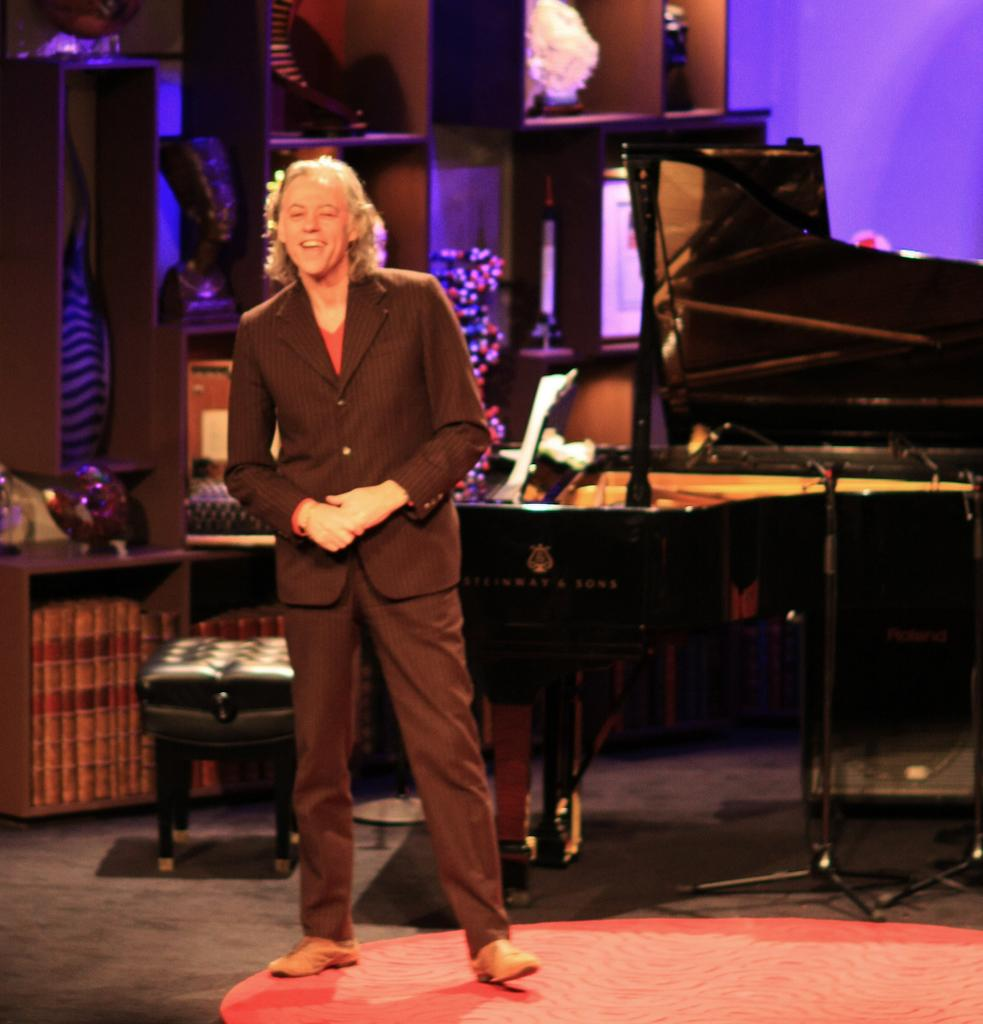What is at the bottom of the image? There is a floor at the bottom of the image. Who or what is in the foreground of the image? There is a person and a chair in the foreground of the image. What is the person doing in the image? The person is likely playing musical instruments, as they are visible in the foreground. What can be seen in the background of the image? There is a wooden rack with objects on it in the background of the image. What type of drug is the person taking in the image? There is no indication in the image that the person is taking any drugs. Can you see a wren perched on the wooden rack in the image? There is no wren present in the image. 